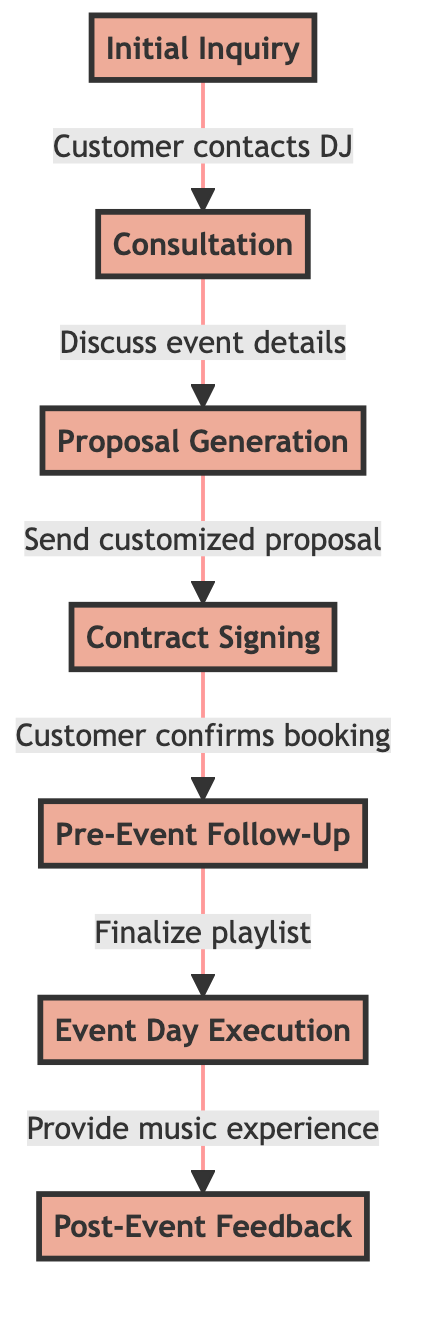What is the first step in the customer service experience flow? The diagram begins with the "Initial Inquiry," which is the first step where customers contact the DJ.
Answer: Initial Inquiry How many total steps are there in the process flow? The flow includes a total of seven steps, from "Initial Inquiry" to "Post-Event Feedback."
Answer: 7 What follows the "Contract Signing" step? After the "Contract Signing," the next step is "Pre-Event Follow-Up," where the DJ checks in with the customer.
Answer: Pre-Event Follow-Up Which step involves the DJ discussing event details? The "Consultation" step is where the DJ discusses event details, such as venue and music preferences, with the customer.
Answer: Consultation What kind of feedback does the DJ request after the event? After the event, the DJ follows up for "Post-Event Feedback," which can include customer feedback and testimonials.
Answer: Feedback What happens during the "Event Day Execution" step? In the "Event Day Execution" step, the DJ provides the music experience and ensures a seamless performance for the event.
Answer: Provide music experience Which two steps are directly connected by a proposal? "Consultation" and "Proposal Generation" are directly connected by the proposal sent after discussing event details.
Answer: Consultation and Proposal Generation What is done during the "Pre-Event Follow-Up"? The "Pre-Event Follow-Up" involves finalizing the playlist and addressing any special requests from the customer.
Answer: Finalize playlist What action does the customer take in the "Contract Signing"? During the "Contract Signing," the customer reviews and signs the contract to confirm their booking.
Answer: Signs the contract 